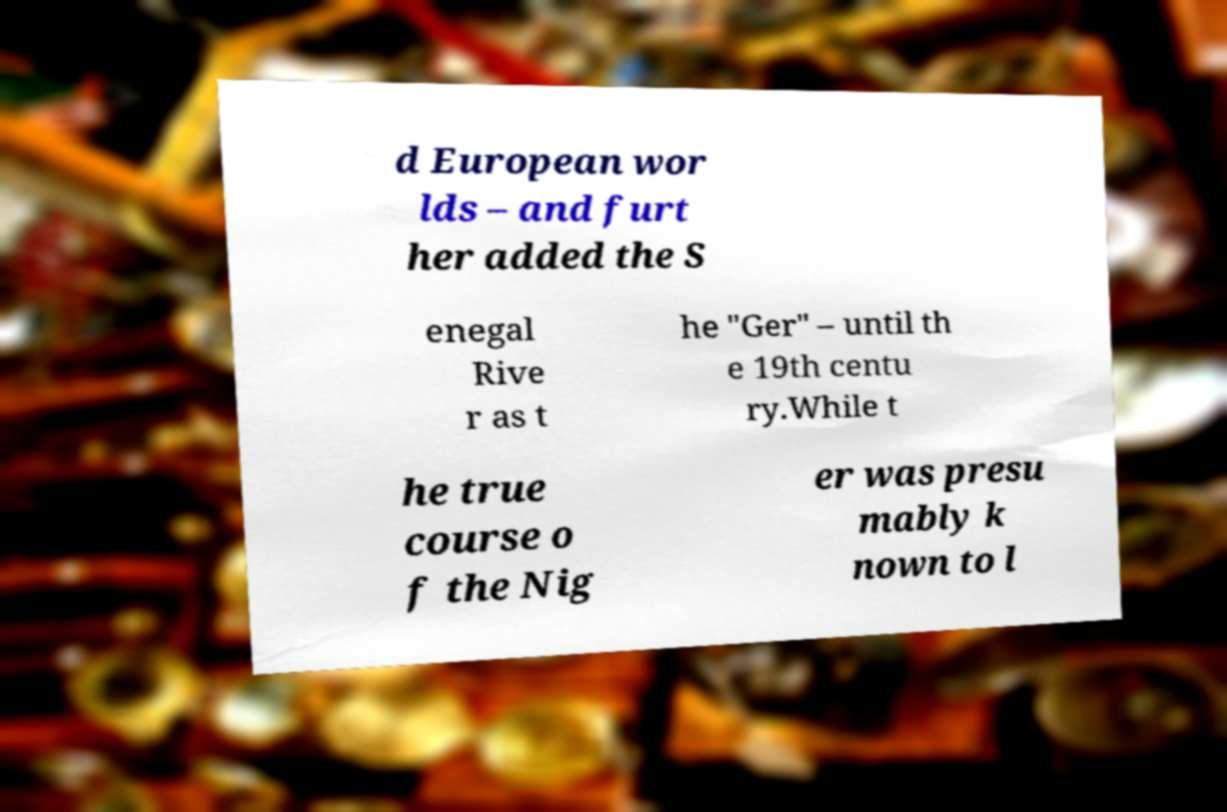Could you assist in decoding the text presented in this image and type it out clearly? d European wor lds – and furt her added the S enegal Rive r as t he "Ger" – until th e 19th centu ry.While t he true course o f the Nig er was presu mably k nown to l 